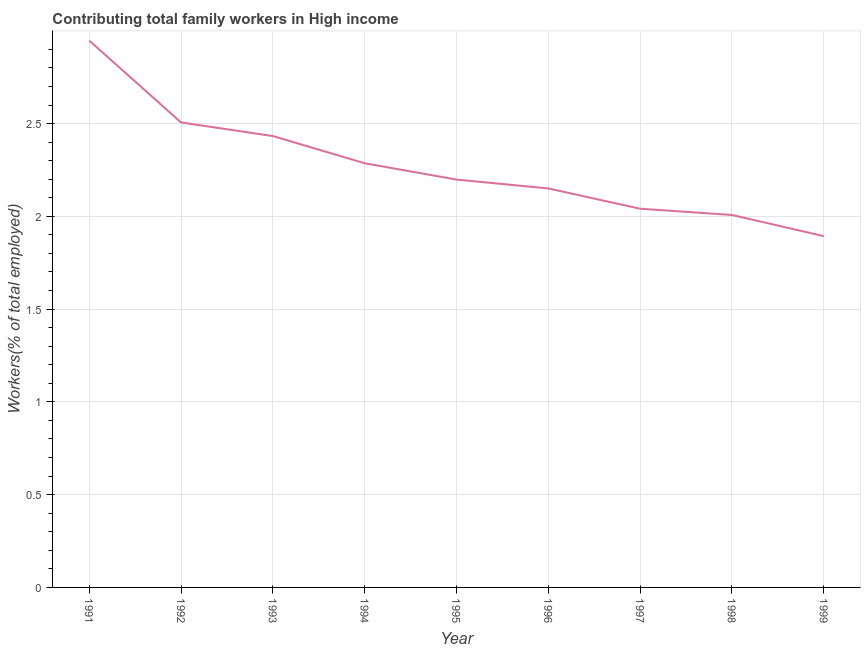What is the contributing family workers in 1992?
Your response must be concise. 2.51. Across all years, what is the maximum contributing family workers?
Offer a terse response. 2.95. Across all years, what is the minimum contributing family workers?
Make the answer very short. 1.89. In which year was the contributing family workers maximum?
Your answer should be compact. 1991. In which year was the contributing family workers minimum?
Ensure brevity in your answer.  1999. What is the sum of the contributing family workers?
Make the answer very short. 20.46. What is the difference between the contributing family workers in 1993 and 1997?
Keep it short and to the point. 0.39. What is the average contributing family workers per year?
Offer a terse response. 2.27. What is the median contributing family workers?
Ensure brevity in your answer.  2.2. Do a majority of the years between 1999 and 1994 (inclusive) have contributing family workers greater than 0.1 %?
Ensure brevity in your answer.  Yes. What is the ratio of the contributing family workers in 1993 to that in 1997?
Make the answer very short. 1.19. Is the contributing family workers in 1991 less than that in 1997?
Provide a succinct answer. No. Is the difference between the contributing family workers in 1994 and 1997 greater than the difference between any two years?
Your answer should be very brief. No. What is the difference between the highest and the second highest contributing family workers?
Your answer should be compact. 0.44. Is the sum of the contributing family workers in 1993 and 1999 greater than the maximum contributing family workers across all years?
Your response must be concise. Yes. What is the difference between the highest and the lowest contributing family workers?
Keep it short and to the point. 1.05. In how many years, is the contributing family workers greater than the average contributing family workers taken over all years?
Offer a terse response. 4. How many years are there in the graph?
Provide a short and direct response. 9. What is the difference between two consecutive major ticks on the Y-axis?
Keep it short and to the point. 0.5. Are the values on the major ticks of Y-axis written in scientific E-notation?
Ensure brevity in your answer.  No. Does the graph contain any zero values?
Keep it short and to the point. No. What is the title of the graph?
Make the answer very short. Contributing total family workers in High income. What is the label or title of the Y-axis?
Give a very brief answer. Workers(% of total employed). What is the Workers(% of total employed) in 1991?
Your answer should be compact. 2.95. What is the Workers(% of total employed) in 1992?
Your answer should be compact. 2.51. What is the Workers(% of total employed) in 1993?
Offer a terse response. 2.43. What is the Workers(% of total employed) in 1994?
Give a very brief answer. 2.29. What is the Workers(% of total employed) in 1995?
Your answer should be compact. 2.2. What is the Workers(% of total employed) of 1996?
Provide a succinct answer. 2.15. What is the Workers(% of total employed) of 1997?
Provide a succinct answer. 2.04. What is the Workers(% of total employed) in 1998?
Offer a very short reply. 2.01. What is the Workers(% of total employed) of 1999?
Provide a succinct answer. 1.89. What is the difference between the Workers(% of total employed) in 1991 and 1992?
Your response must be concise. 0.44. What is the difference between the Workers(% of total employed) in 1991 and 1993?
Offer a terse response. 0.51. What is the difference between the Workers(% of total employed) in 1991 and 1994?
Keep it short and to the point. 0.66. What is the difference between the Workers(% of total employed) in 1991 and 1995?
Give a very brief answer. 0.75. What is the difference between the Workers(% of total employed) in 1991 and 1996?
Your response must be concise. 0.8. What is the difference between the Workers(% of total employed) in 1991 and 1997?
Offer a very short reply. 0.91. What is the difference between the Workers(% of total employed) in 1991 and 1998?
Offer a terse response. 0.94. What is the difference between the Workers(% of total employed) in 1991 and 1999?
Offer a very short reply. 1.05. What is the difference between the Workers(% of total employed) in 1992 and 1993?
Keep it short and to the point. 0.07. What is the difference between the Workers(% of total employed) in 1992 and 1994?
Offer a terse response. 0.22. What is the difference between the Workers(% of total employed) in 1992 and 1995?
Your answer should be compact. 0.31. What is the difference between the Workers(% of total employed) in 1992 and 1996?
Provide a succinct answer. 0.36. What is the difference between the Workers(% of total employed) in 1992 and 1997?
Offer a very short reply. 0.46. What is the difference between the Workers(% of total employed) in 1992 and 1998?
Your answer should be compact. 0.5. What is the difference between the Workers(% of total employed) in 1992 and 1999?
Provide a short and direct response. 0.61. What is the difference between the Workers(% of total employed) in 1993 and 1994?
Provide a succinct answer. 0.15. What is the difference between the Workers(% of total employed) in 1993 and 1995?
Provide a succinct answer. 0.23. What is the difference between the Workers(% of total employed) in 1993 and 1996?
Provide a succinct answer. 0.28. What is the difference between the Workers(% of total employed) in 1993 and 1997?
Ensure brevity in your answer.  0.39. What is the difference between the Workers(% of total employed) in 1993 and 1998?
Your answer should be very brief. 0.43. What is the difference between the Workers(% of total employed) in 1993 and 1999?
Provide a short and direct response. 0.54. What is the difference between the Workers(% of total employed) in 1994 and 1995?
Give a very brief answer. 0.09. What is the difference between the Workers(% of total employed) in 1994 and 1996?
Keep it short and to the point. 0.14. What is the difference between the Workers(% of total employed) in 1994 and 1997?
Offer a terse response. 0.25. What is the difference between the Workers(% of total employed) in 1994 and 1998?
Give a very brief answer. 0.28. What is the difference between the Workers(% of total employed) in 1994 and 1999?
Provide a succinct answer. 0.39. What is the difference between the Workers(% of total employed) in 1995 and 1996?
Your answer should be compact. 0.05. What is the difference between the Workers(% of total employed) in 1995 and 1997?
Keep it short and to the point. 0.16. What is the difference between the Workers(% of total employed) in 1995 and 1998?
Give a very brief answer. 0.19. What is the difference between the Workers(% of total employed) in 1995 and 1999?
Make the answer very short. 0.3. What is the difference between the Workers(% of total employed) in 1996 and 1997?
Offer a very short reply. 0.11. What is the difference between the Workers(% of total employed) in 1996 and 1998?
Make the answer very short. 0.14. What is the difference between the Workers(% of total employed) in 1996 and 1999?
Provide a short and direct response. 0.26. What is the difference between the Workers(% of total employed) in 1997 and 1998?
Keep it short and to the point. 0.03. What is the difference between the Workers(% of total employed) in 1997 and 1999?
Offer a very short reply. 0.15. What is the difference between the Workers(% of total employed) in 1998 and 1999?
Offer a terse response. 0.11. What is the ratio of the Workers(% of total employed) in 1991 to that in 1992?
Your response must be concise. 1.18. What is the ratio of the Workers(% of total employed) in 1991 to that in 1993?
Provide a succinct answer. 1.21. What is the ratio of the Workers(% of total employed) in 1991 to that in 1994?
Offer a terse response. 1.29. What is the ratio of the Workers(% of total employed) in 1991 to that in 1995?
Give a very brief answer. 1.34. What is the ratio of the Workers(% of total employed) in 1991 to that in 1996?
Keep it short and to the point. 1.37. What is the ratio of the Workers(% of total employed) in 1991 to that in 1997?
Make the answer very short. 1.44. What is the ratio of the Workers(% of total employed) in 1991 to that in 1998?
Provide a short and direct response. 1.47. What is the ratio of the Workers(% of total employed) in 1991 to that in 1999?
Your answer should be compact. 1.56. What is the ratio of the Workers(% of total employed) in 1992 to that in 1994?
Your answer should be compact. 1.1. What is the ratio of the Workers(% of total employed) in 1992 to that in 1995?
Keep it short and to the point. 1.14. What is the ratio of the Workers(% of total employed) in 1992 to that in 1996?
Make the answer very short. 1.17. What is the ratio of the Workers(% of total employed) in 1992 to that in 1997?
Keep it short and to the point. 1.23. What is the ratio of the Workers(% of total employed) in 1992 to that in 1998?
Keep it short and to the point. 1.25. What is the ratio of the Workers(% of total employed) in 1992 to that in 1999?
Offer a terse response. 1.32. What is the ratio of the Workers(% of total employed) in 1993 to that in 1994?
Ensure brevity in your answer.  1.06. What is the ratio of the Workers(% of total employed) in 1993 to that in 1995?
Your response must be concise. 1.11. What is the ratio of the Workers(% of total employed) in 1993 to that in 1996?
Give a very brief answer. 1.13. What is the ratio of the Workers(% of total employed) in 1993 to that in 1997?
Provide a short and direct response. 1.19. What is the ratio of the Workers(% of total employed) in 1993 to that in 1998?
Provide a succinct answer. 1.21. What is the ratio of the Workers(% of total employed) in 1993 to that in 1999?
Ensure brevity in your answer.  1.28. What is the ratio of the Workers(% of total employed) in 1994 to that in 1996?
Make the answer very short. 1.06. What is the ratio of the Workers(% of total employed) in 1994 to that in 1997?
Keep it short and to the point. 1.12. What is the ratio of the Workers(% of total employed) in 1994 to that in 1998?
Give a very brief answer. 1.14. What is the ratio of the Workers(% of total employed) in 1994 to that in 1999?
Your answer should be compact. 1.21. What is the ratio of the Workers(% of total employed) in 1995 to that in 1997?
Provide a short and direct response. 1.08. What is the ratio of the Workers(% of total employed) in 1995 to that in 1998?
Provide a short and direct response. 1.09. What is the ratio of the Workers(% of total employed) in 1995 to that in 1999?
Offer a terse response. 1.16. What is the ratio of the Workers(% of total employed) in 1996 to that in 1997?
Ensure brevity in your answer.  1.05. What is the ratio of the Workers(% of total employed) in 1996 to that in 1998?
Ensure brevity in your answer.  1.07. What is the ratio of the Workers(% of total employed) in 1996 to that in 1999?
Give a very brief answer. 1.14. What is the ratio of the Workers(% of total employed) in 1997 to that in 1998?
Offer a terse response. 1.02. What is the ratio of the Workers(% of total employed) in 1997 to that in 1999?
Offer a very short reply. 1.08. What is the ratio of the Workers(% of total employed) in 1998 to that in 1999?
Make the answer very short. 1.06. 